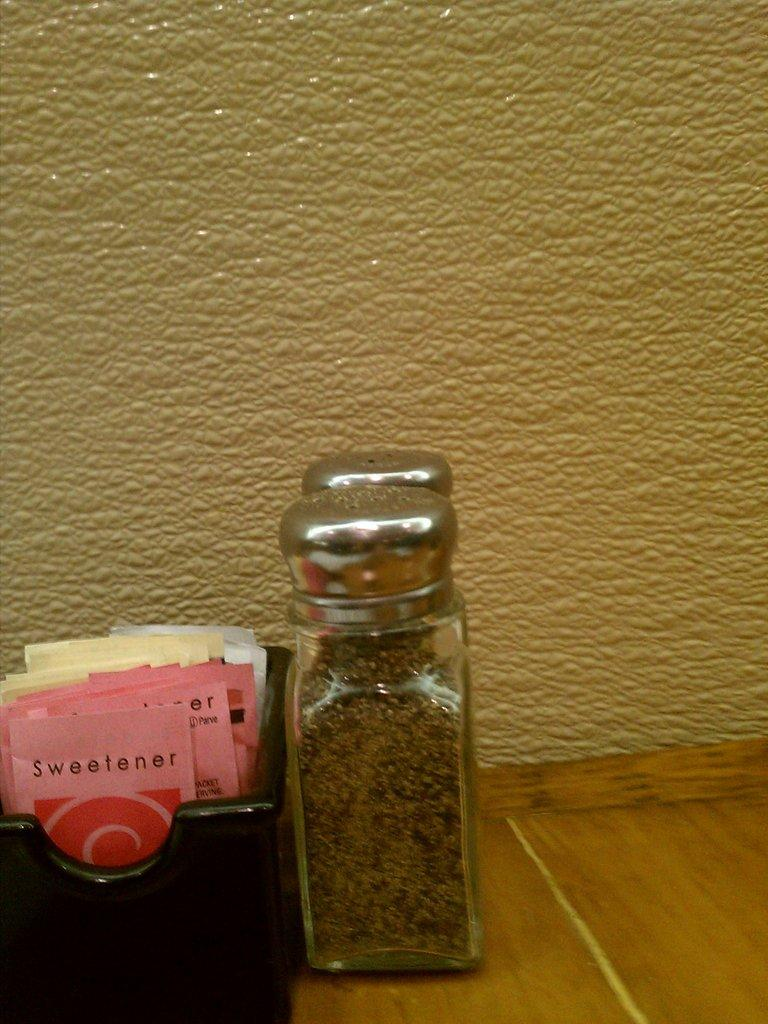What is the main object in the center of the image? There is a table in the center of the image. What is placed on the table? There is a bottle and papers on the table. What can be seen in the background of the image? There is a wall in the background of the image. What type of crack can be seen on the map in the image? There is no map present in the image, so there is no crack to observe. Is there a chessboard visible on the table in the image? There is no chessboard visible on the table in the image. 